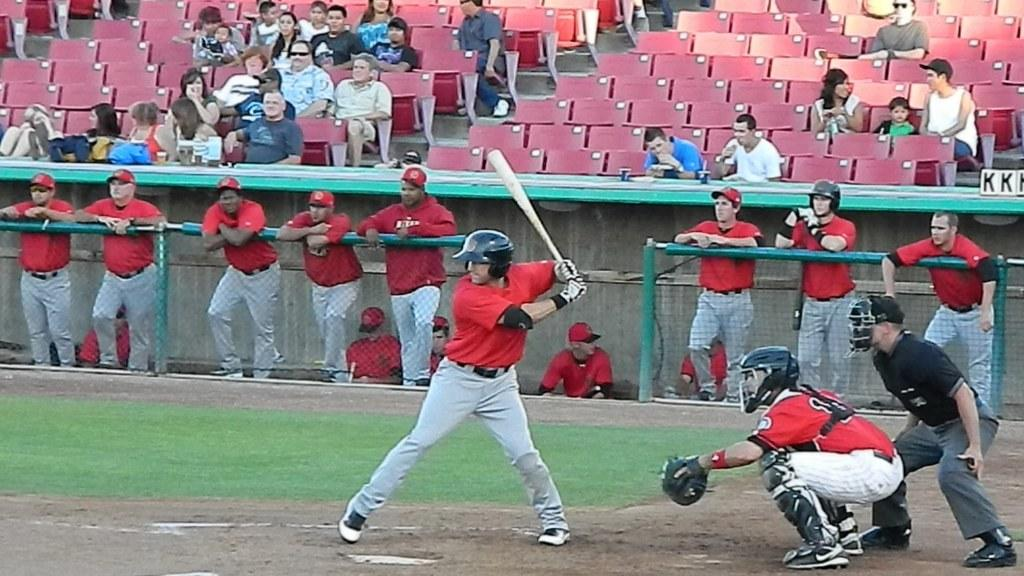Provide a one-sentence caption for the provided image. The letters KK behind a baseball player waiting to play. 